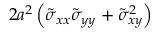<formula> <loc_0><loc_0><loc_500><loc_500>2 a ^ { 2 } \left ( \tilde { \sigma } _ { x x } \tilde { \sigma } _ { y y } + \tilde { \sigma } _ { x y } ^ { 2 } \right )</formula> 